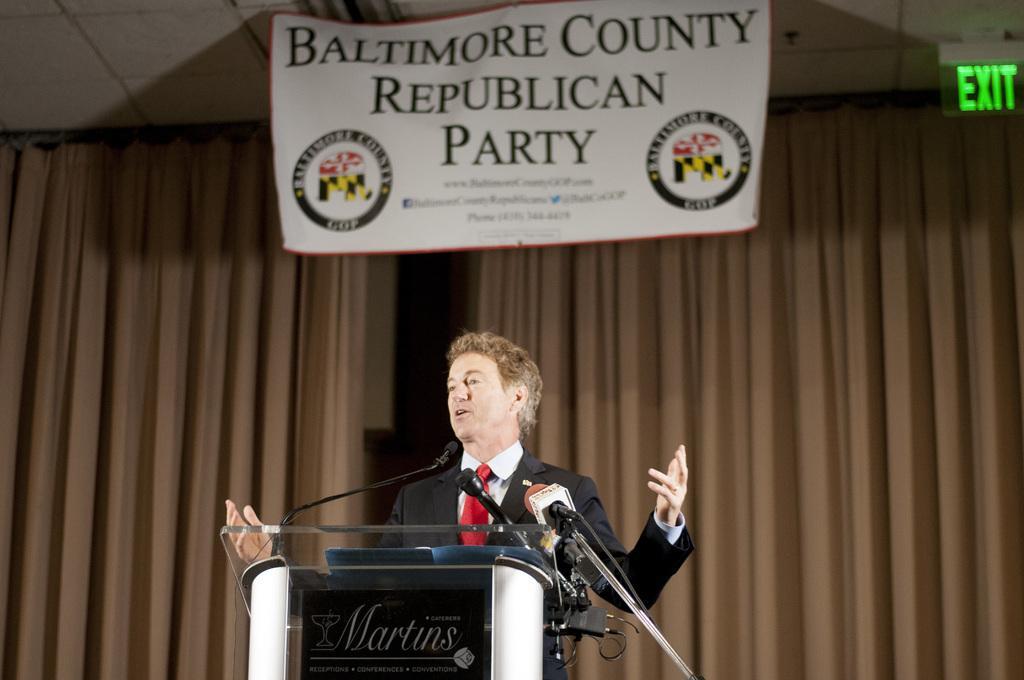In one or two sentences, can you explain what this image depicts? In this image I can see a man is standing and I can see he is wearing a blazer, a red tie and a white shirt. In the front of him, I can see a podium and few mics. On the front side of the podium I can see a black colour board and on it I can see something is written. In the background I can see two curtains, a white colour board and on it I can see something is written. On the top right side of the image I can see an exit sign board on the ceiling. 